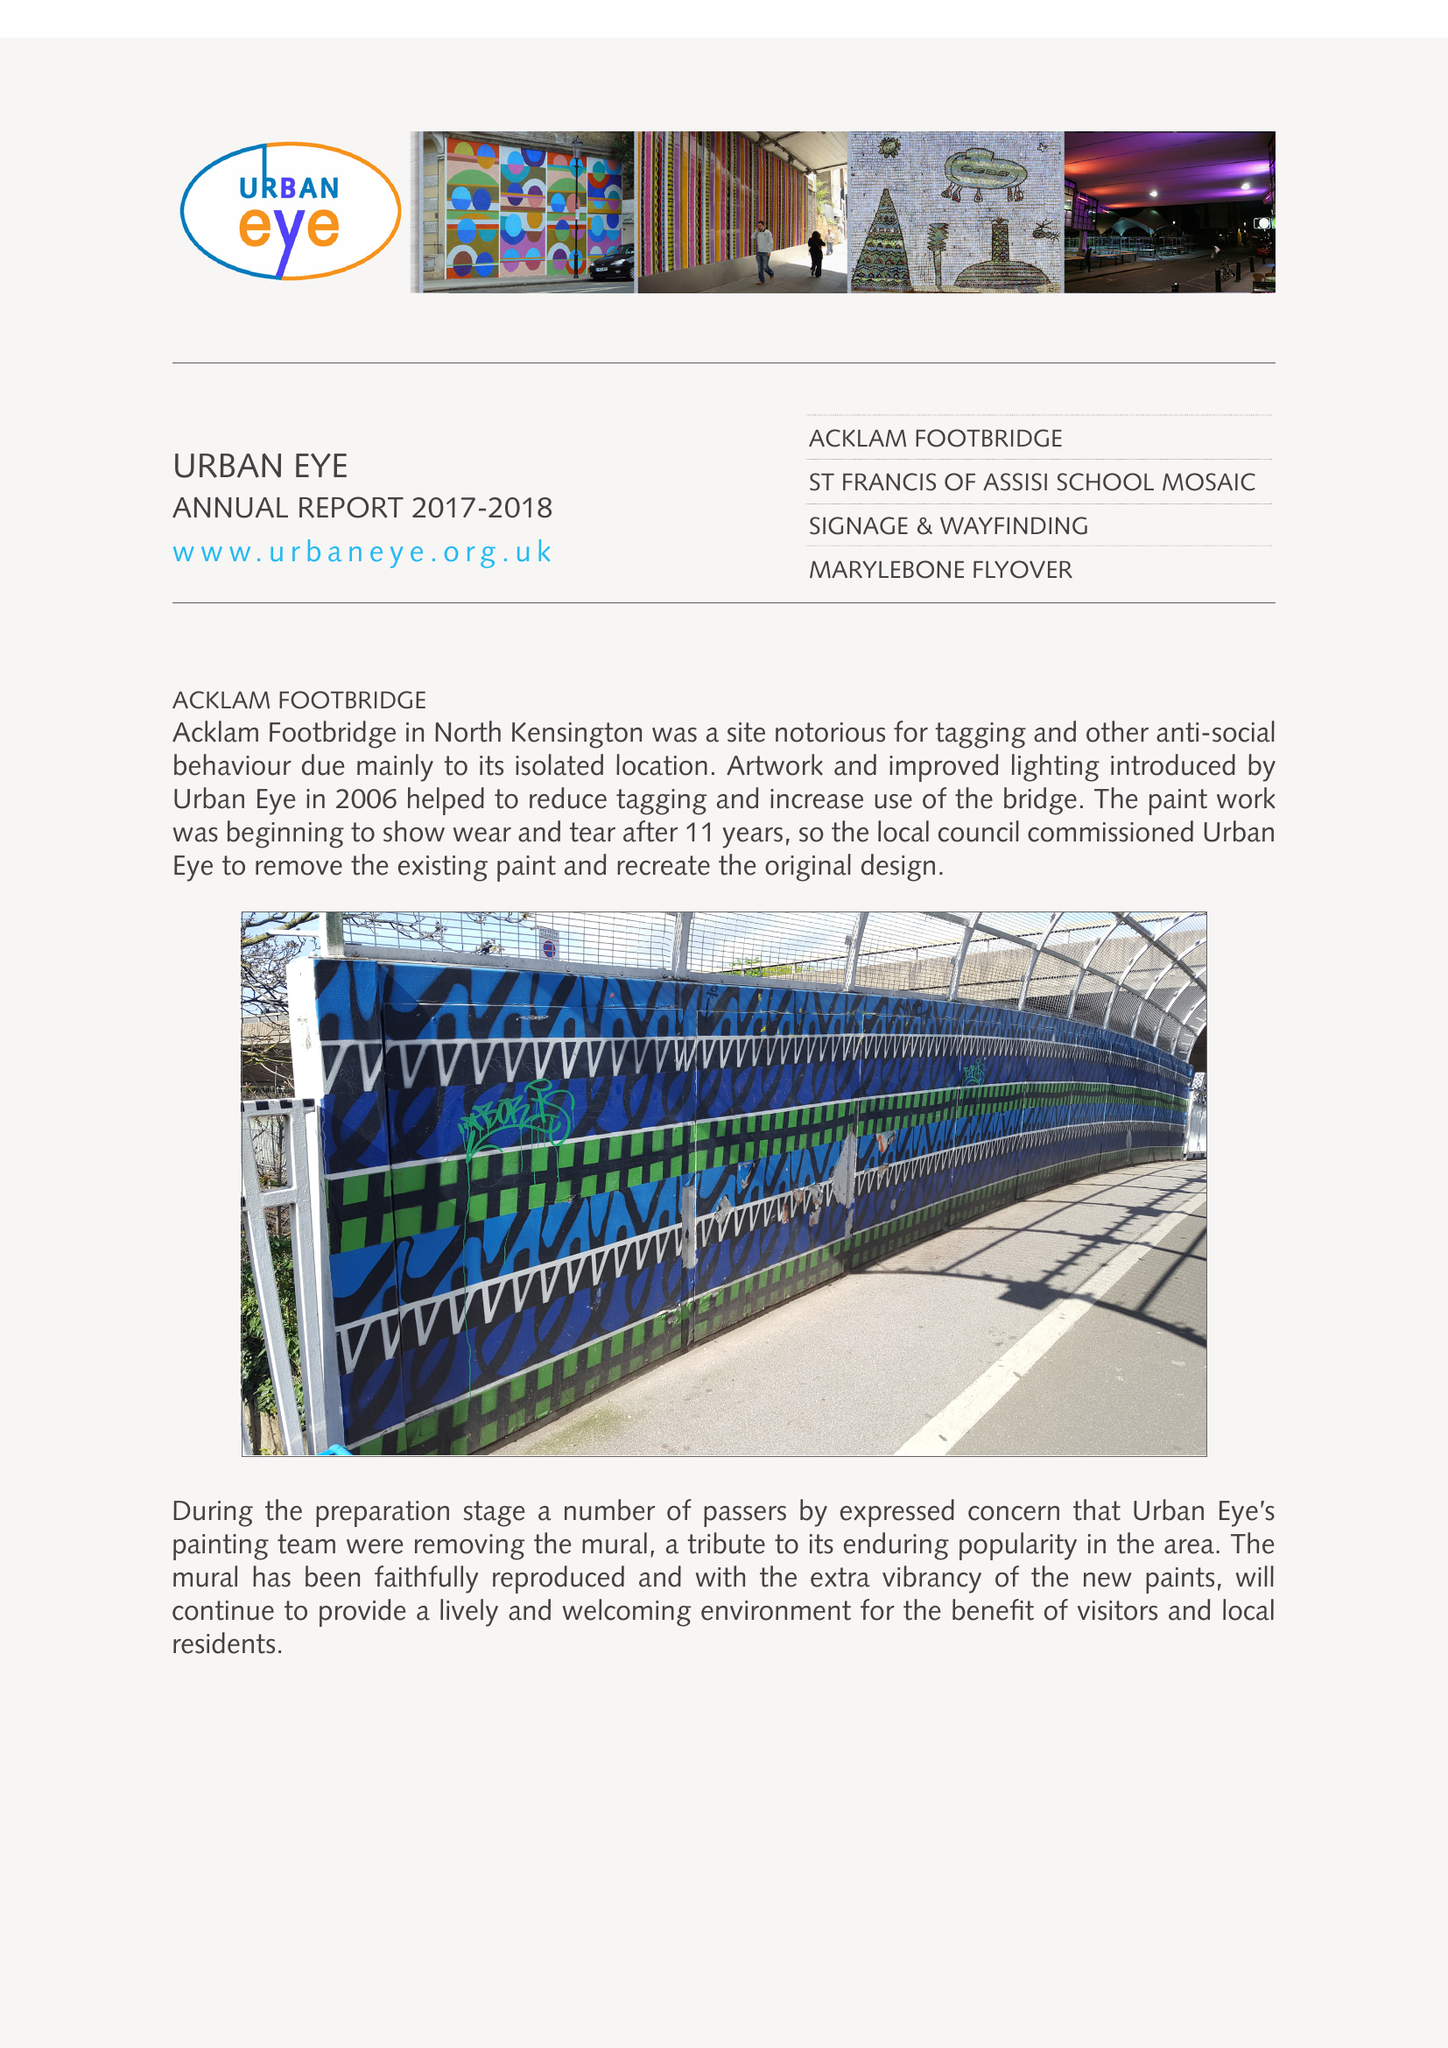What is the value for the address__street_line?
Answer the question using a single word or phrase. WHITCHURCH ROAD 